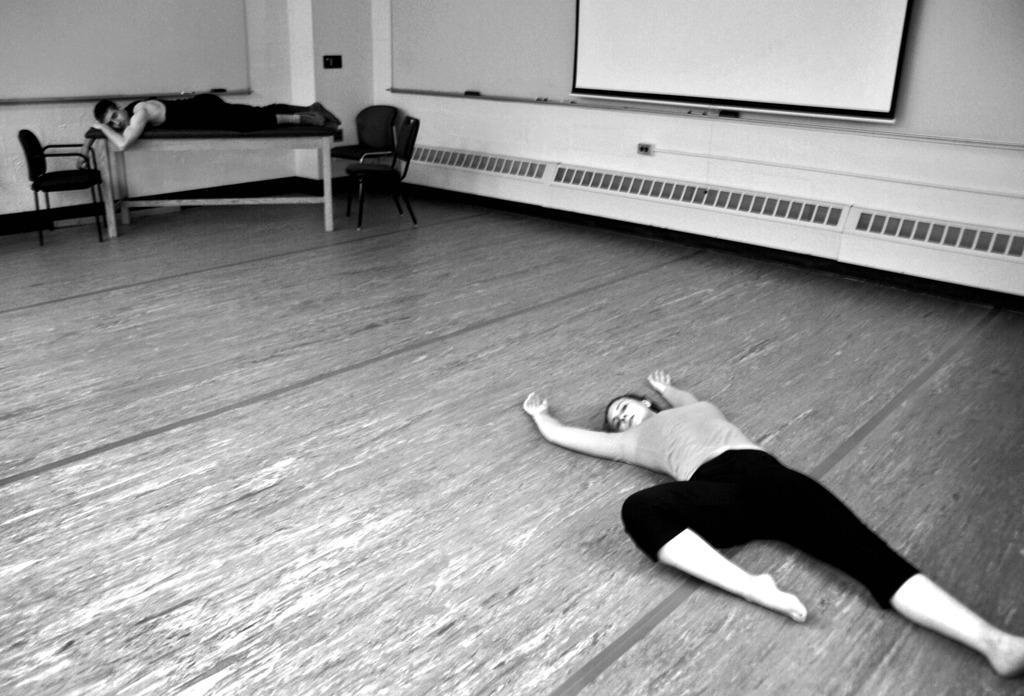Can you describe this image briefly? This is a black and white image. On the right side there is a woman laying on the floor. In the background there is a another person laying on a table. Beside the table there are few empty chairs. In the background, I can see the wall on which a screen is attached. 